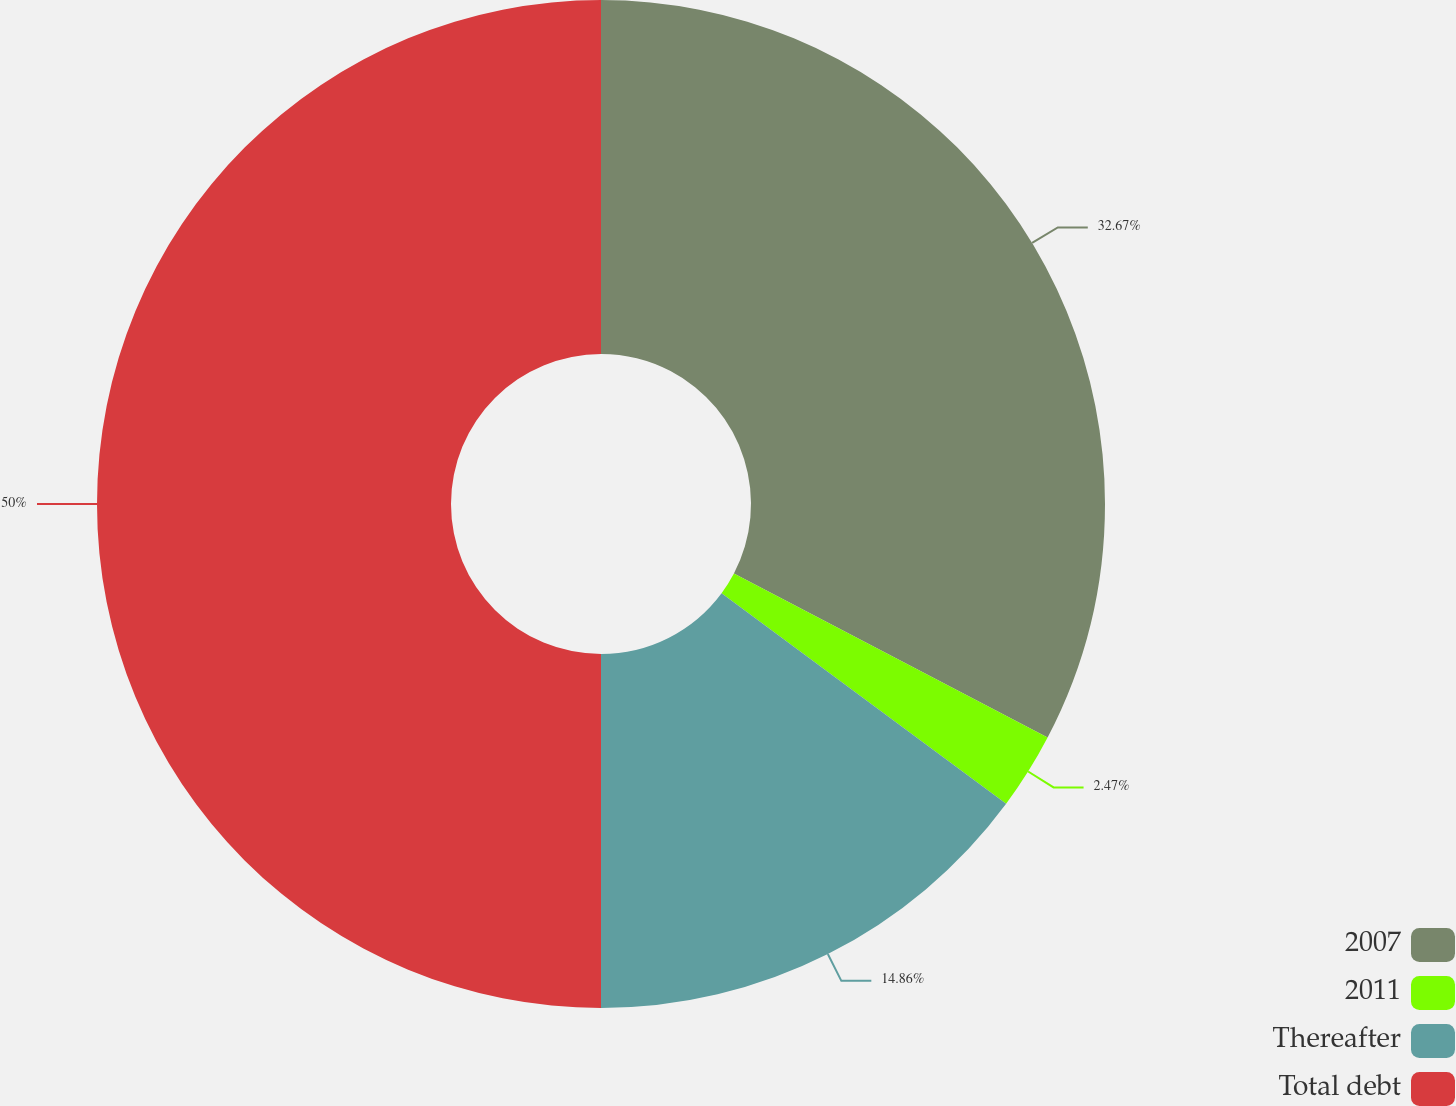Convert chart. <chart><loc_0><loc_0><loc_500><loc_500><pie_chart><fcel>2007<fcel>2011<fcel>Thereafter<fcel>Total debt<nl><fcel>32.67%<fcel>2.47%<fcel>14.86%<fcel>50.0%<nl></chart> 